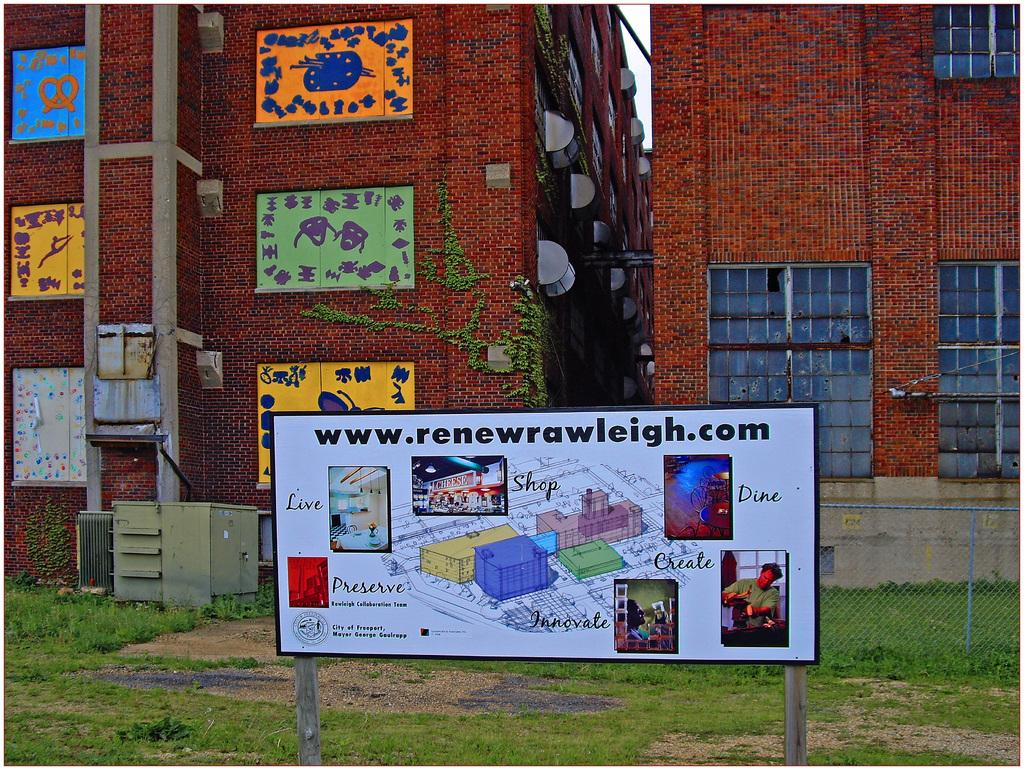Provide a one-sentence caption for the provided image. An sign for www.renewrawleigh.com in the city of Freeport. 